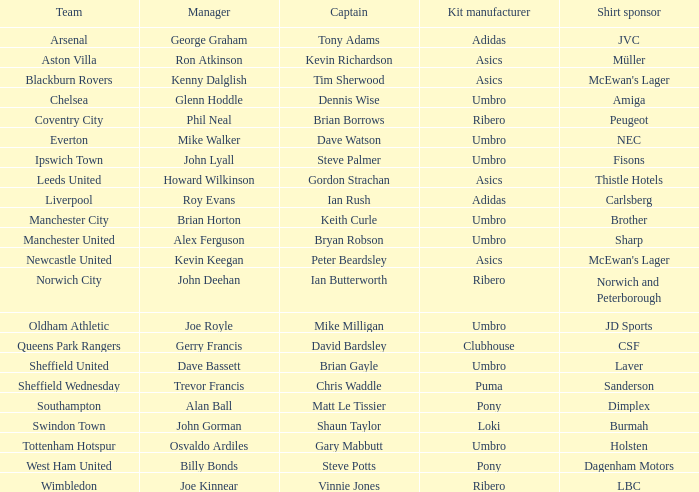Which manager has Manchester City as the team? Brian Horton. 